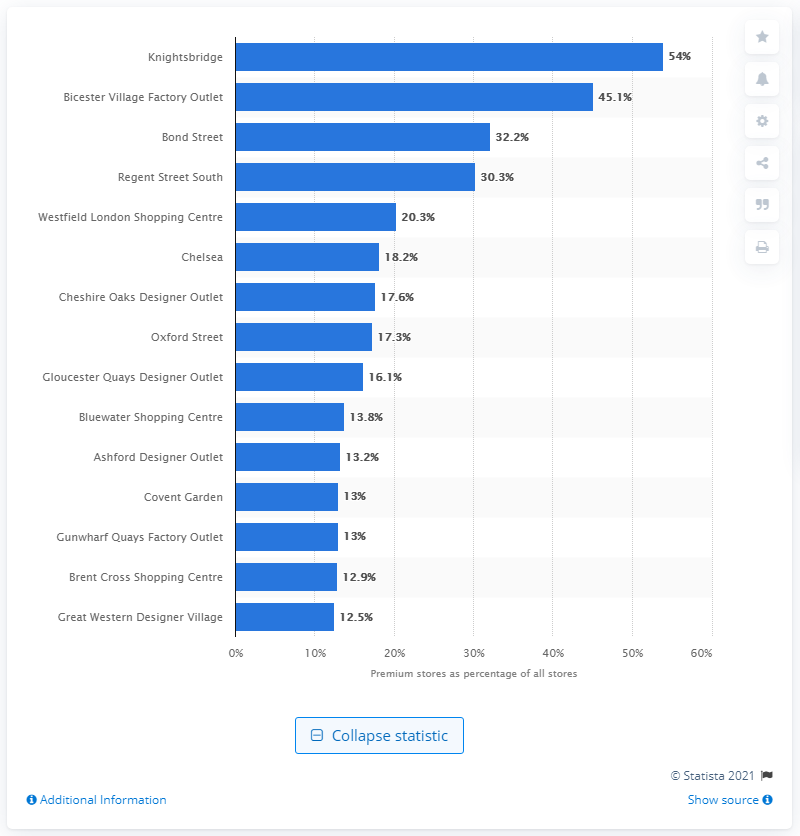Specify some key components in this picture. In 2014, Knightsbridge was the highest ranked premium retail center in the United Kingdom. 